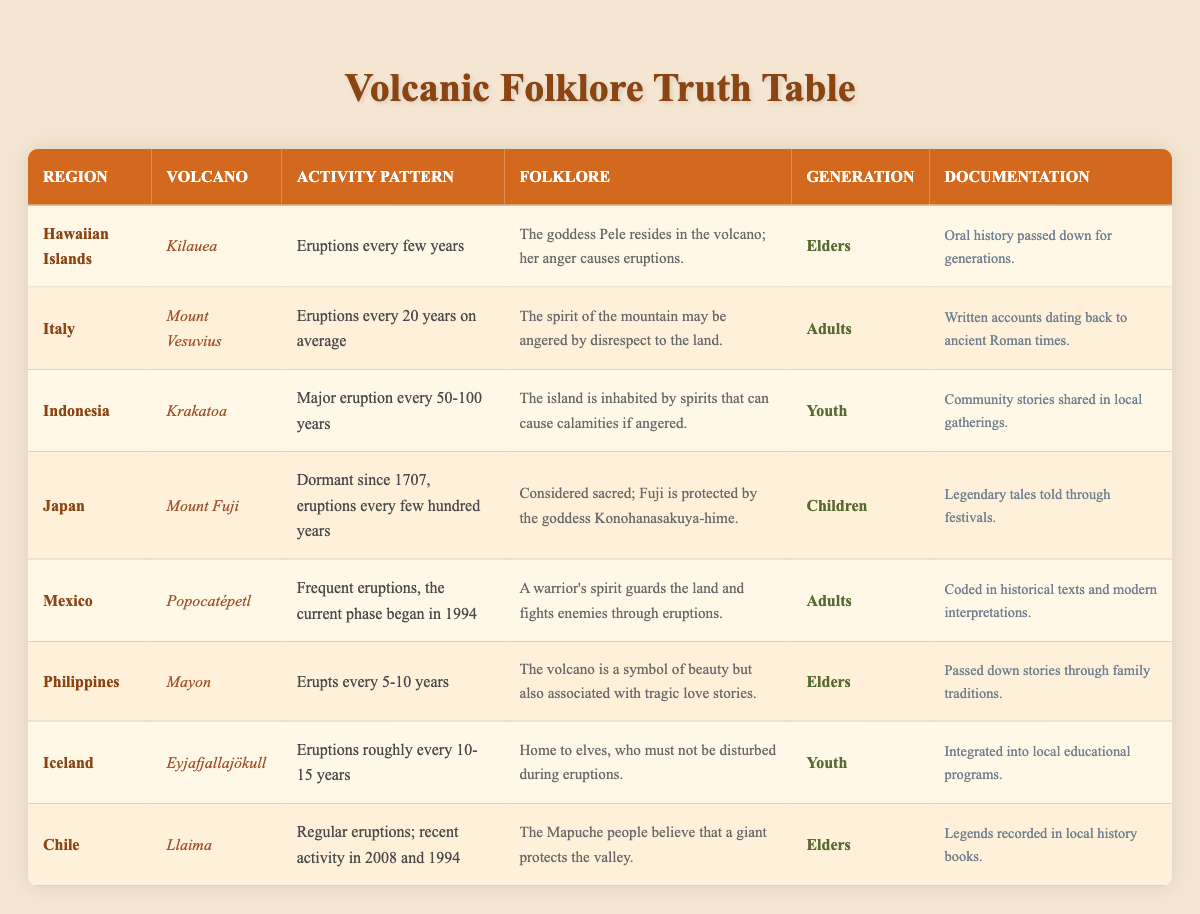What is the eruption frequency of Mayon volcano? According to the table, Mayon erupts every 5-10 years. This specific information can be found in the row related to the Philippines and Mayon volcano.
Answer: Erupts every 5-10 years Which generation shares the folklore about Kilauea and what is its documentation? The row for Kilauea reveals that the elders share the associated folklore, which is documented as oral history passed down for generations.
Answer: Elders; Oral history passed down for generations Is the folklore of Mount Fuji told through written documents? The information in the table specifies that the folklore of Mount Fuji is conveyed through legendary tales told during festivals, which implies that it is not primarily documented in written form.
Answer: No How many volcanoes have a pattern of eruptions every few years? By examining the table, two volcanoes have this pattern: Kilauea (Hawaiian Islands) and Mayon (Philippines).
Answer: 2 volcanoes What is the average eruption interval for Krakatoa and Mount Vesuvius? Krakatoa has major eruptions every 50-100 years, while Mount Vesuvius has eruptions every 20 years on average. To find an average eruption interval, take the easier intervals as follows: For Krakatoa, the mid-point would be (50+100)/2 = 75 years. Then calculate the average of 75 and 20 by (75 + 20)/2 = 47.5 years. The answer provides a rough average of eruption intervals for both volcanoes.
Answer: 47.5 years Which volcano is associated with spirits causing calamities if angered? The folklore for Krakatoa states that the island is inhabited by spirits that can cause calamities if they are angered, as noted in the Indonesia row.
Answer: Krakatoa 